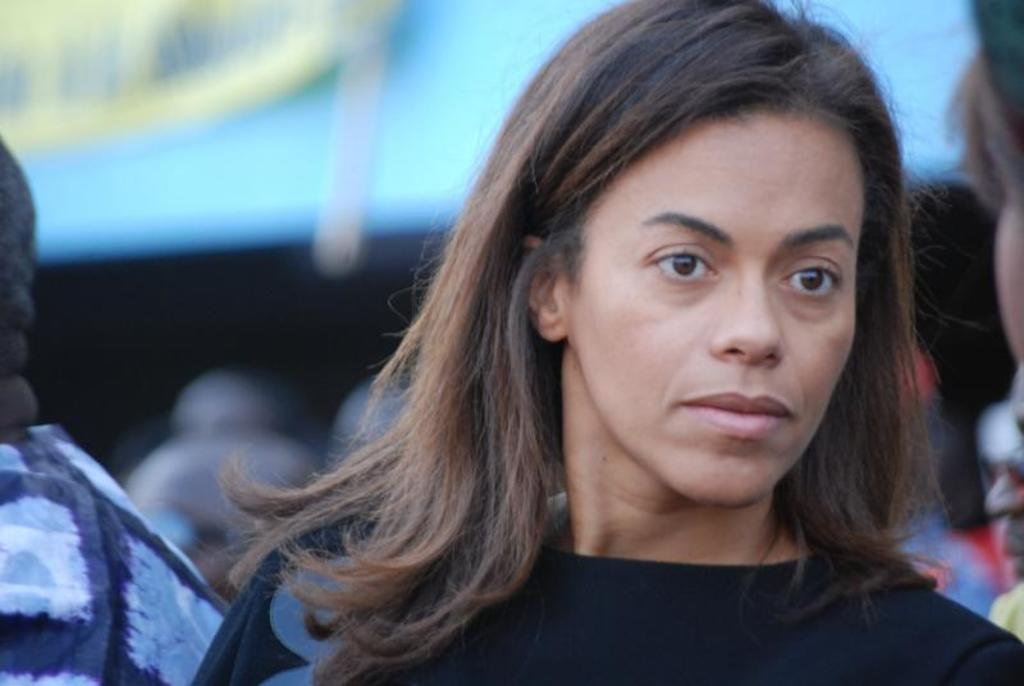Where is the woman located in the image? The woman is standing in the bottom right side of the image. Are there any other people in the image? Yes, there are people standing behind the woman. What type of can is visible in the wilderness in the image? There is no can or wilderness present in the image. 